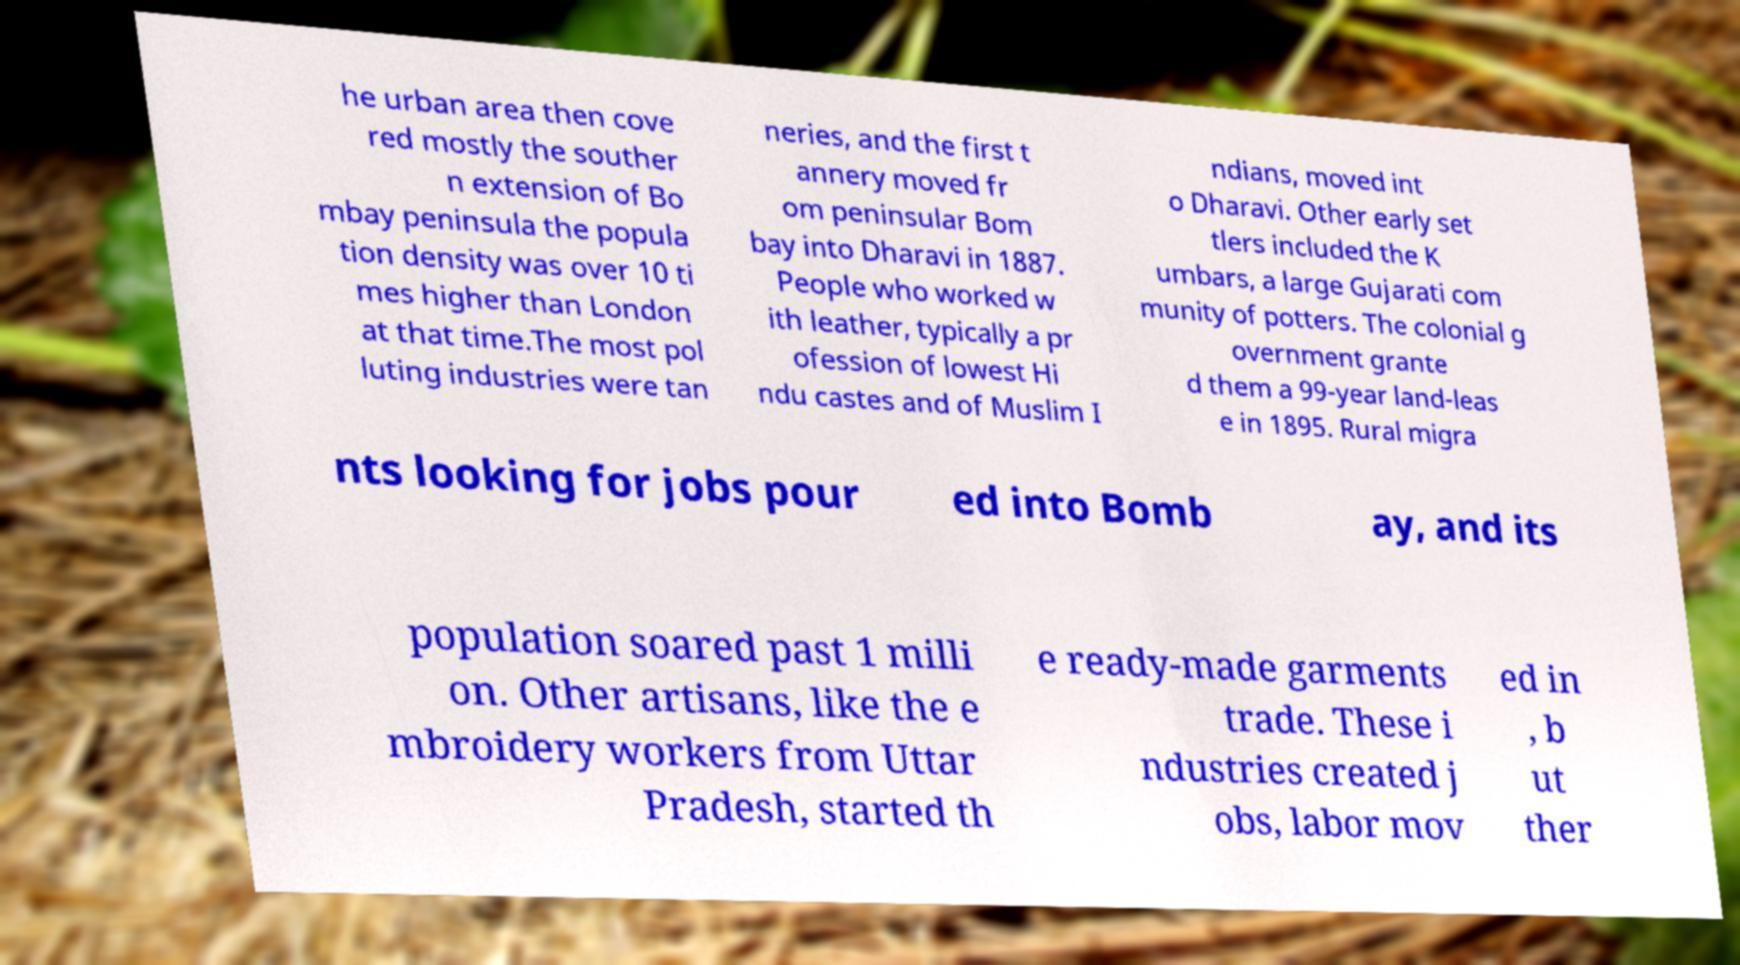I need the written content from this picture converted into text. Can you do that? he urban area then cove red mostly the souther n extension of Bo mbay peninsula the popula tion density was over 10 ti mes higher than London at that time.The most pol luting industries were tan neries, and the first t annery moved fr om peninsular Bom bay into Dharavi in 1887. People who worked w ith leather, typically a pr ofession of lowest Hi ndu castes and of Muslim I ndians, moved int o Dharavi. Other early set tlers included the K umbars, a large Gujarati com munity of potters. The colonial g overnment grante d them a 99-year land-leas e in 1895. Rural migra nts looking for jobs pour ed into Bomb ay, and its population soared past 1 milli on. Other artisans, like the e mbroidery workers from Uttar Pradesh, started th e ready-made garments trade. These i ndustries created j obs, labor mov ed in , b ut ther 